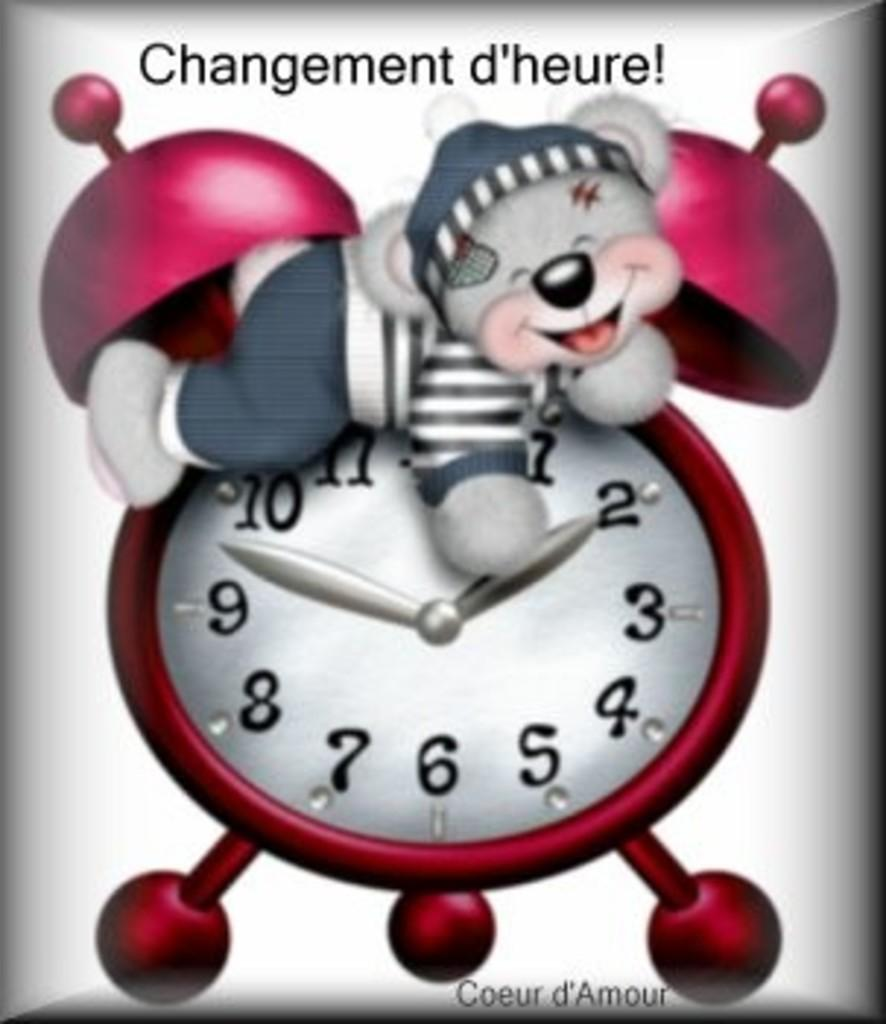<image>
Relay a brief, clear account of the picture shown. Alarmclock with a teddy bear like creature on the top has a label that says "Changement d'heure" 